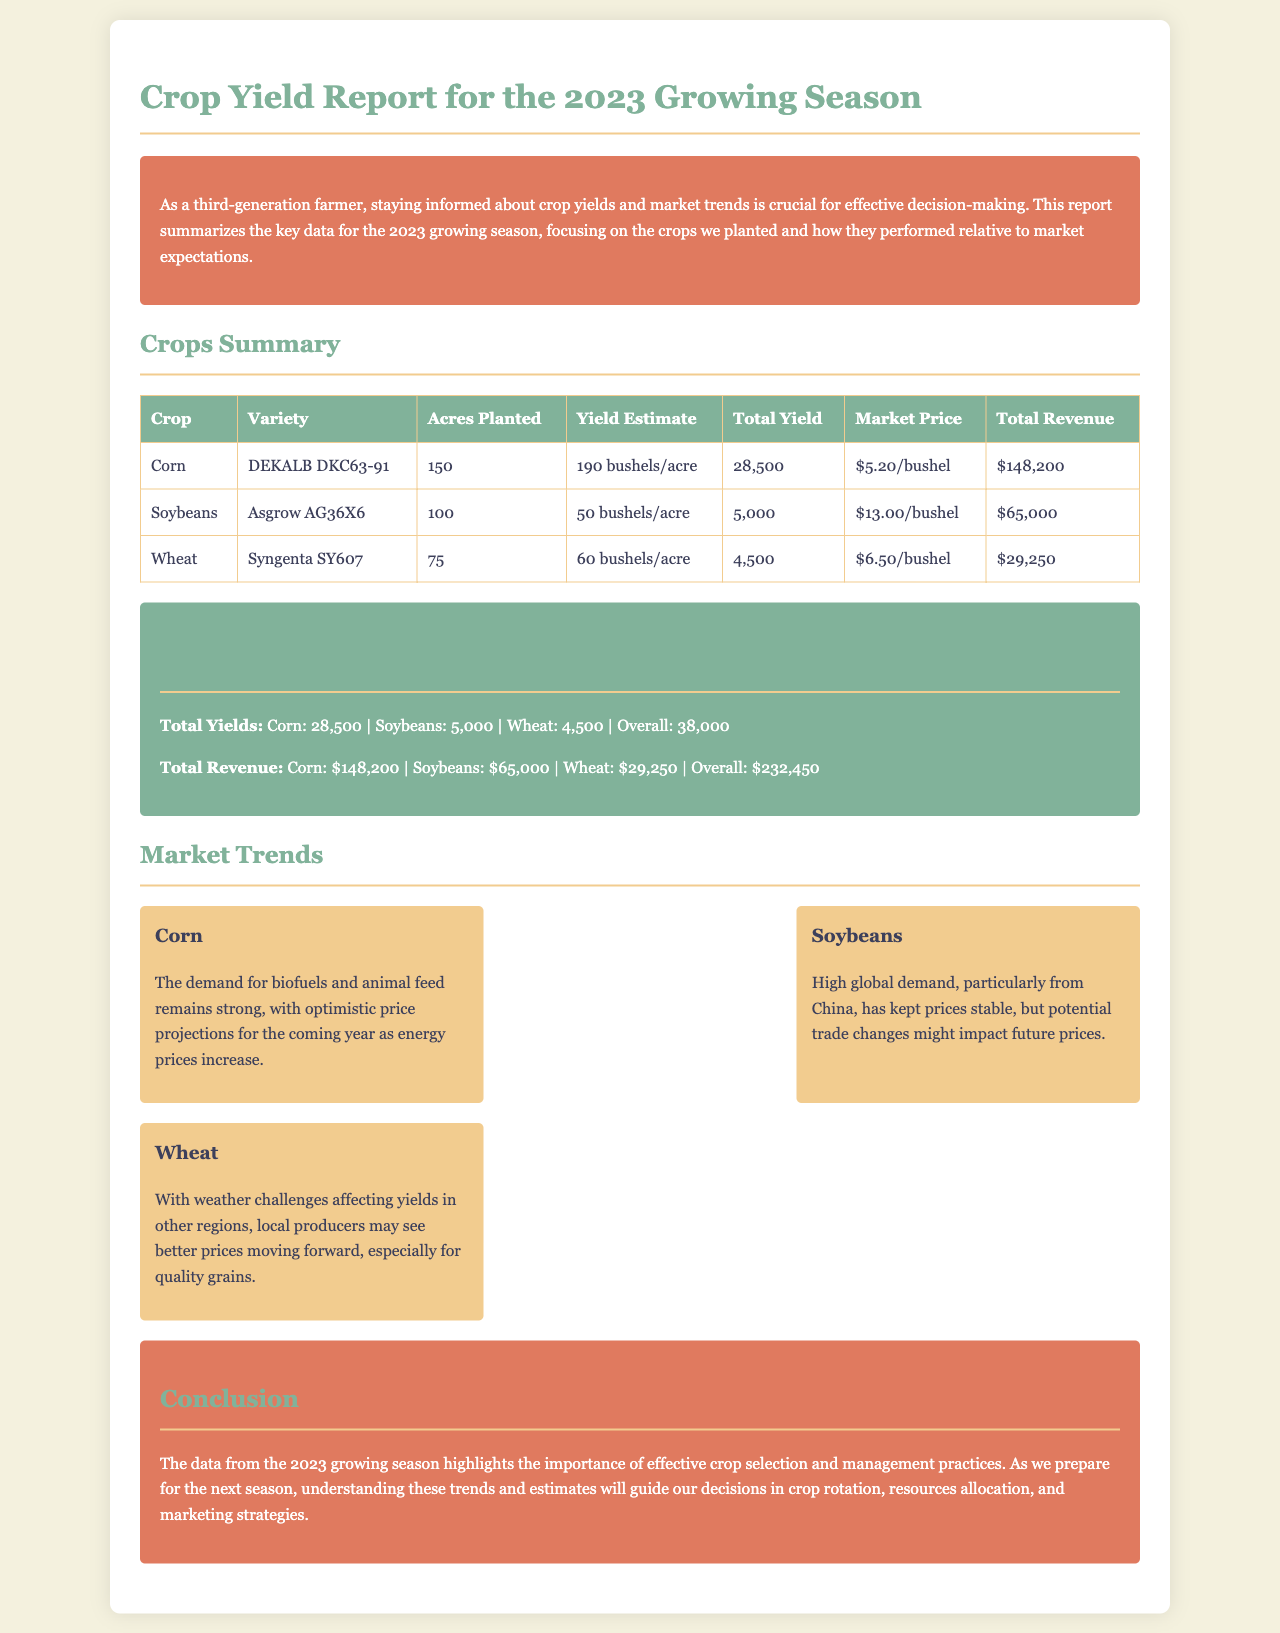What is the total yield for corn? The total yield for corn is stated in the "Total Yields" section at 28,500.
Answer: 28,500 What is the market price for soybeans? The market price for soybeans is listed in the crops summary table as $13.00/bushel.
Answer: $13.00/bushel How many acres of wheat were planted? The area for wheat planted is found in the crops summary table, which indicates 75 acres.
Answer: 75 What is the overall total revenue? The overall total revenue is provided in the "Total Revenue" summary as $232,450.
Answer: $232,450 Which crop has the highest yield estimate? The crop with the highest yield estimate can be determined by comparing the yield estimates listed, which indicates corn at 190 bushels/acre.
Answer: Corn What market trend is highlighted for wheat? The document mentions that local producers may see better prices for wheat due to weather challenges affecting yields in other regions.
Answer: Better prices for quality grains What variety of corn is planted? The corn variety is listed in the crops summary as DEKALB DKC63-91.
Answer: DEKALB DKC63-91 What is the conclusion about crop management? The conclusion emphasizes the importance of effective crop selection and management practices for future decisions.
Answer: Effective crop selection and management practices 